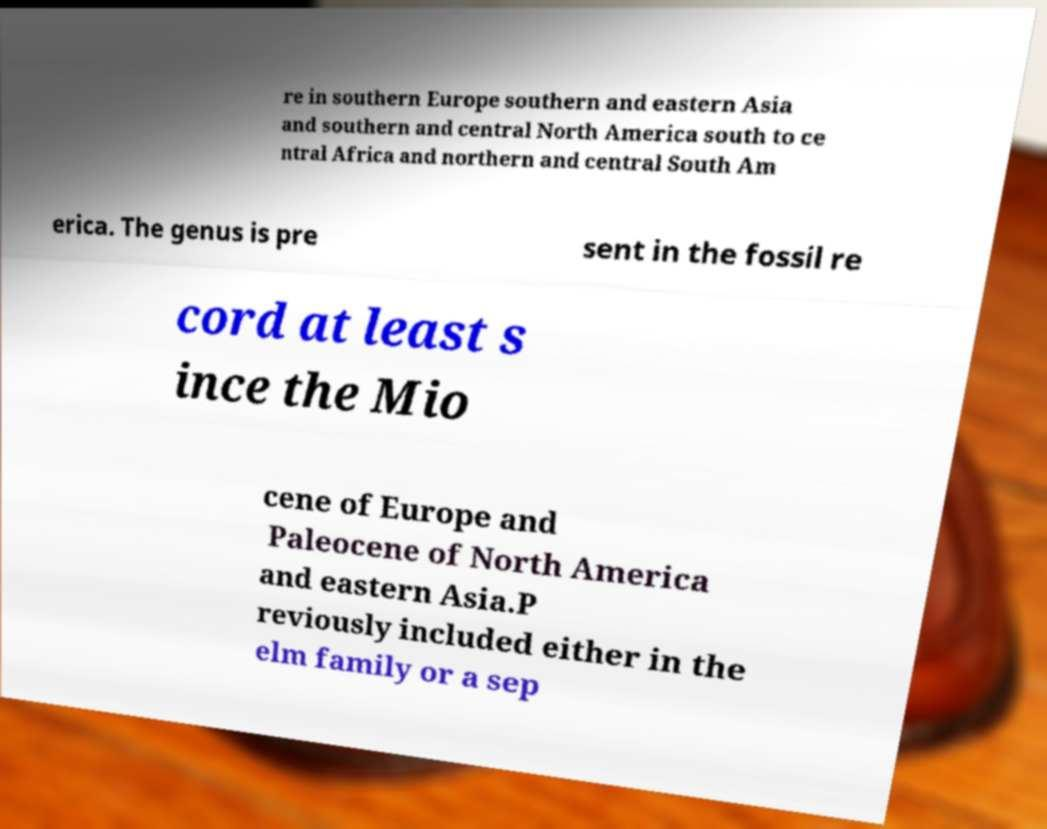Could you extract and type out the text from this image? re in southern Europe southern and eastern Asia and southern and central North America south to ce ntral Africa and northern and central South Am erica. The genus is pre sent in the fossil re cord at least s ince the Mio cene of Europe and Paleocene of North America and eastern Asia.P reviously included either in the elm family or a sep 